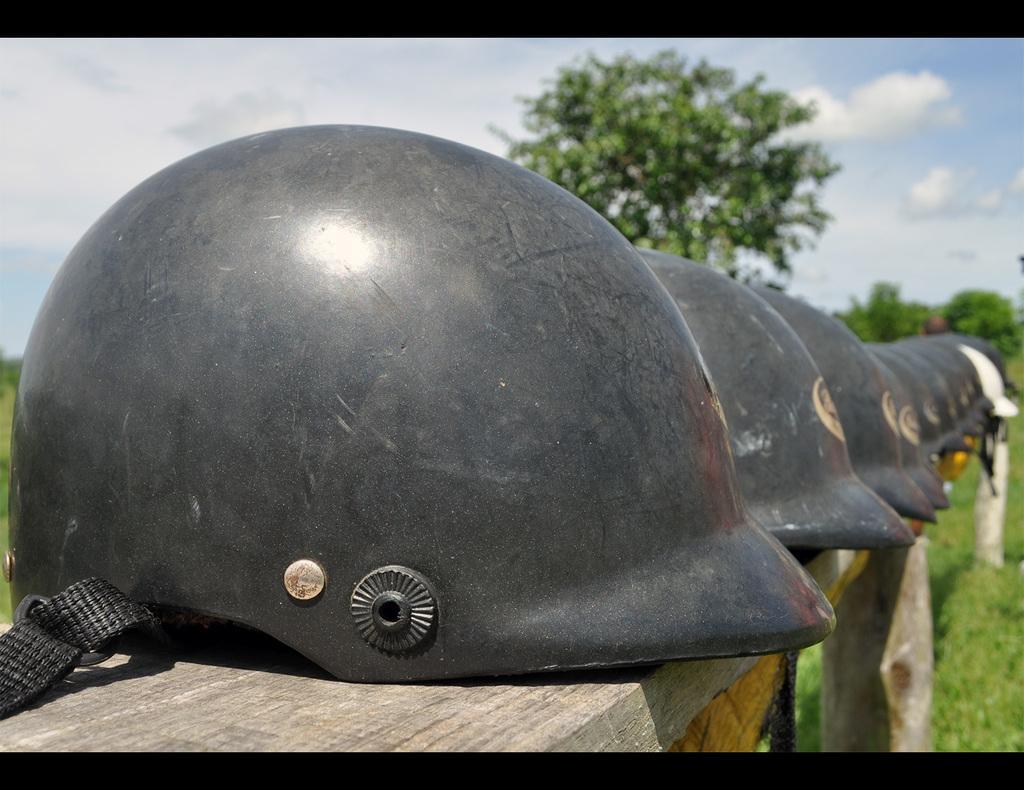Describe this image in one or two sentences. In this picture we can see many helmets on this wooden rack. On the right we can see green grass. In the background we can see many trees. At the top we can see sky and clouds. 